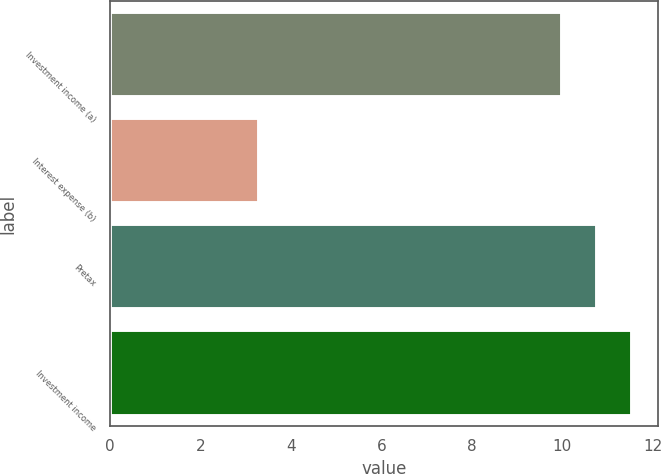Convert chart. <chart><loc_0><loc_0><loc_500><loc_500><bar_chart><fcel>Investment income (a)<fcel>Interest expense (b)<fcel>Pretax<fcel>Investment income<nl><fcel>10<fcel>3.3<fcel>10.77<fcel>11.54<nl></chart> 